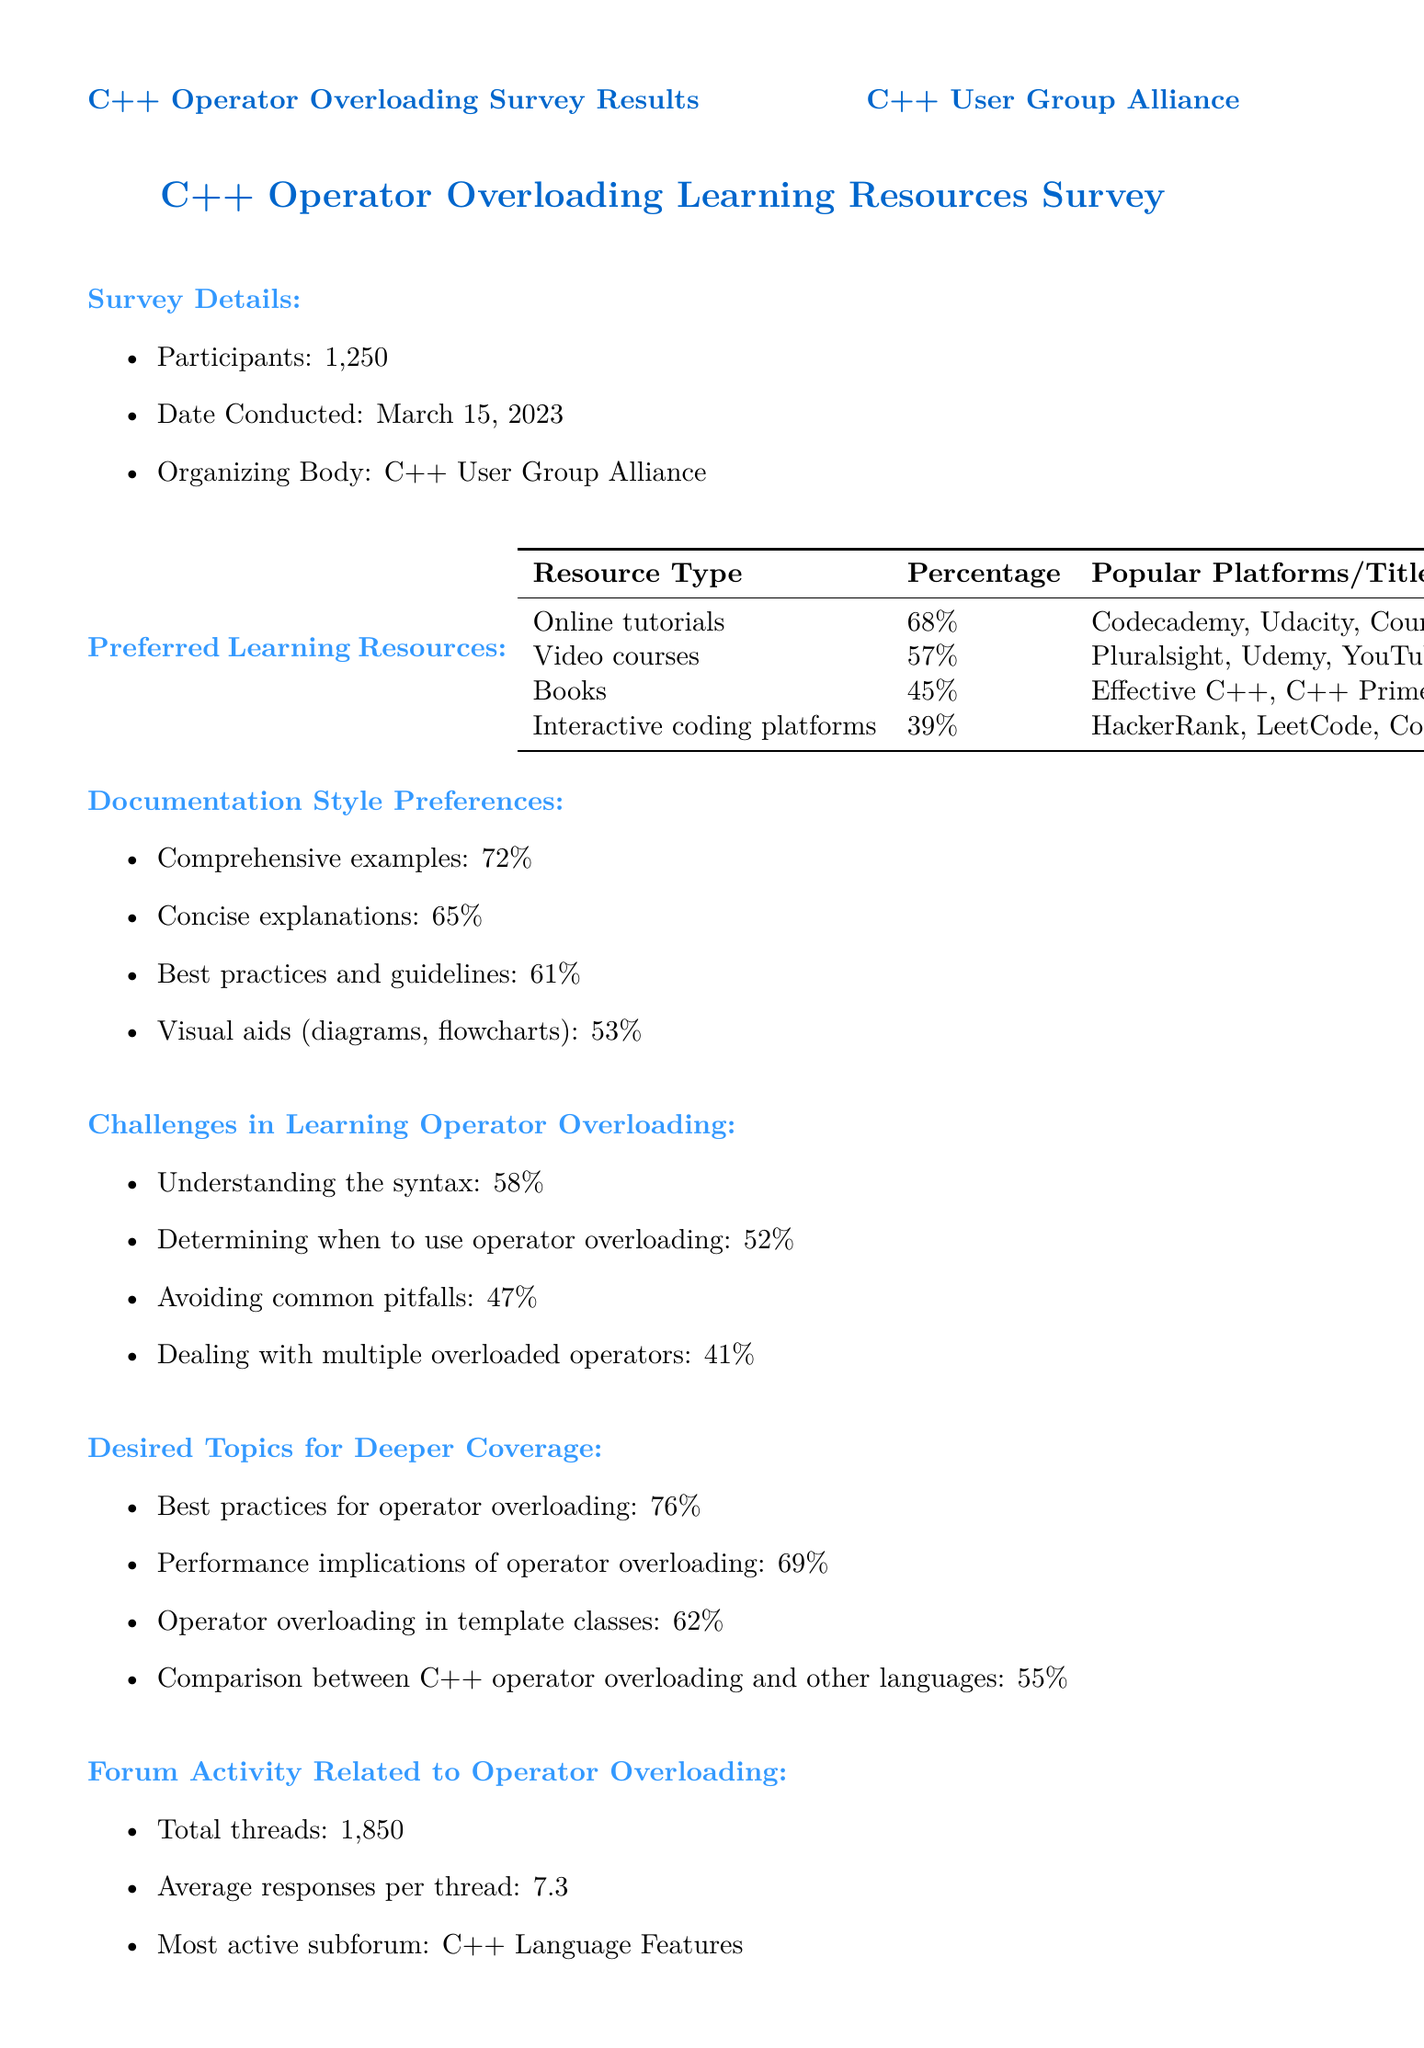what is the date the survey was conducted? The date of the survey is specifically mentioned in the document.
Answer: March 15, 2023 how many participants were in the survey? The number of participants is clearly stated in the document.
Answer: 1,250 which resource type is preferred by the highest percentage of respondents? This information requires comparison among the different resource types listed.
Answer: Online tutorials what is the percentage of respondents who prefer comprehensive examples in documentation? This value is listed under documentation style preferences.
Answer: 72% what is the challenge related to determining when to use operator overloading? This challenge is part of the challenges mentioned in the document, requiring recall of the specific challenge listed.
Answer: 52 which community recommendation received the highest percentage? This question looks for the recommendation percentage that is noted as highest in the document.
Answer: More interactive examples in documentation how many total threads are there related to operator overloading in the forum? The total number of threads is indicated in the section concerning forum activity.
Answer: 1,850 what topic had the least interest for deeper coverage according to the respondents? This question requires identifying the topic with the lowest percentage from the desired topics section.
Answer: Comparison between C++ operator overloading and other languages who were the top contributors in the forum activity? This requires recalling the names listed under forum activity.
Answer: JohnDoe123, CppExpert42, OverloadMaster 